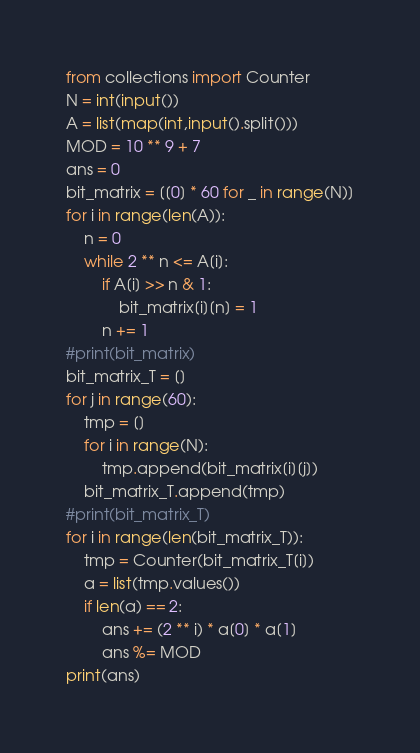Convert code to text. <code><loc_0><loc_0><loc_500><loc_500><_Python_>from collections import Counter
N = int(input())
A = list(map(int,input().split()))
MOD = 10 ** 9 + 7
ans = 0
bit_matrix = [[0] * 60 for _ in range(N)]
for i in range(len(A)):
    n = 0
    while 2 ** n <= A[i]:
        if A[i] >> n & 1:
            bit_matrix[i][n] = 1
        n += 1
#print(bit_matrix)
bit_matrix_T = []
for j in range(60):
    tmp = []
    for i in range(N):
        tmp.append(bit_matrix[i][j])
    bit_matrix_T.append(tmp)
#print(bit_matrix_T)
for i in range(len(bit_matrix_T)):
    tmp = Counter(bit_matrix_T[i])
    a = list(tmp.values())
    if len(a) == 2:
        ans += (2 ** i) * a[0] * a[1]
        ans %= MOD
print(ans)
</code> 